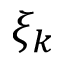<formula> <loc_0><loc_0><loc_500><loc_500>\xi _ { k }</formula> 